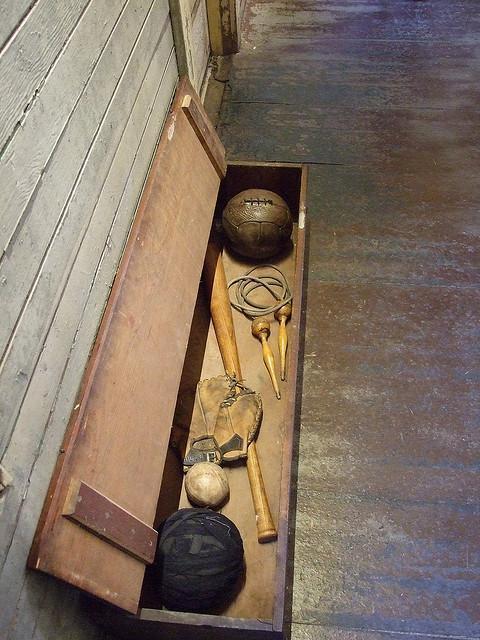How many balls are in the picture?
Give a very brief answer. 3. 